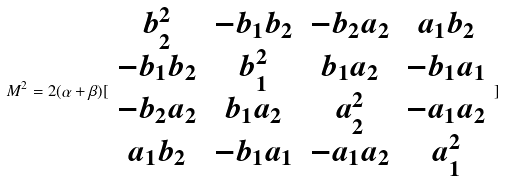Convert formula to latex. <formula><loc_0><loc_0><loc_500><loc_500>M ^ { 2 } = 2 ( \alpha + \beta ) [ \begin{array} { c c c c } b _ { 2 } ^ { 2 } & - b _ { 1 } b _ { 2 } & - b _ { 2 } a _ { 2 } & a _ { 1 } b _ { 2 } \\ - b _ { 1 } b _ { 2 } & b _ { 1 } ^ { 2 } & b _ { 1 } a _ { 2 } & - b _ { 1 } a _ { 1 } \\ - b _ { 2 } a _ { 2 } & b _ { 1 } a _ { 2 } & a _ { 2 } ^ { 2 } & - a _ { 1 } a _ { 2 } \\ a _ { 1 } b _ { 2 } & - b _ { 1 } a _ { 1 } & - a _ { 1 } a _ { 2 } & a _ { 1 } ^ { 2 } \end{array} ]</formula> 